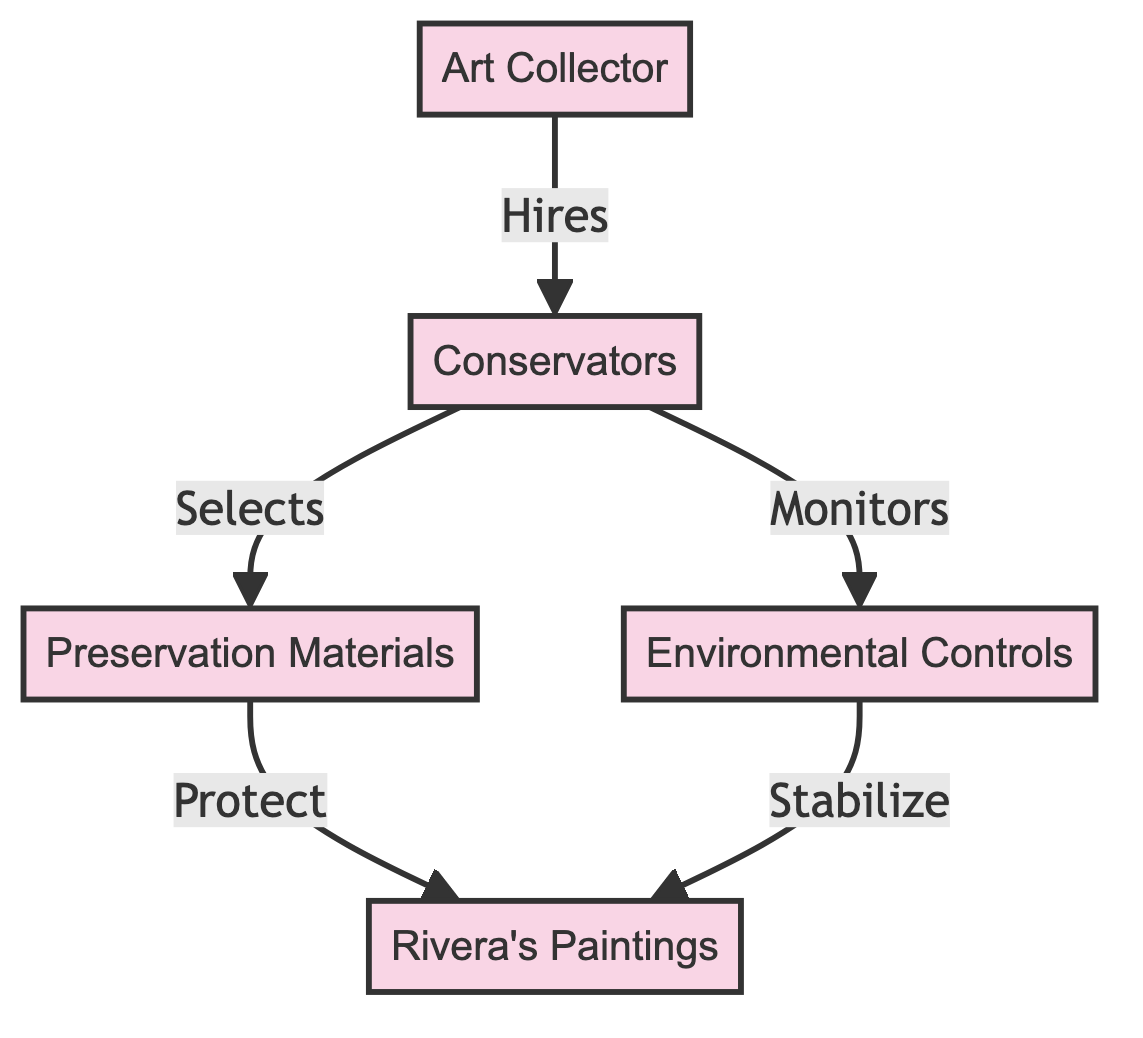What role does the art collector play in the ecosystem? The art collector hires conservators, indicating their role as a supporter and provider of resources to maintain the integrity of the art.
Answer: Hires What do conservators select? According to the diagram, conservators specifically select preservation materials as part of their tasks to ensure the paintings are well maintained.
Answer: Preservation Materials How many edges are in the diagram? The diagram shows five connections between the nodes, which are the relationships illustrated in the flow of the ecosystem.
Answer: Five What do environmental controls stabilize? The environmental controls are shown to stabilize Rivera's paintings, ensuring that the conditions are optimal for preserving the artwork.
Answer: Rivera's Paintings What is the direct action between conservators and environmental controls? The conservators monitor environmental controls, highlighting their role in overseeing the conditions that influence the preservation of the art.
Answer: Monitors Which node is the end beneficiary of preservation materials? The direct beneficiary of the preservation materials is Rivera's paintings, as they are protected through the application of these materials.
Answer: Rivera's Paintings What is the first action taken in this ecosystem? The first action depicted in the diagram is the hiring of conservators by the art collector, establishing the management of the preservation efforts.
Answer: Hires Which node does the preservation materials protect? The preservation materials are specifically designed to protect Rivera's paintings, indicating their importance in the preservation process.
Answer: Rivera's Paintings What type of node is the art collector? The art collector is classified as a distinct node in the diagram that initiates the interactions and relationships depicted in the ecosystem.
Answer: Node 